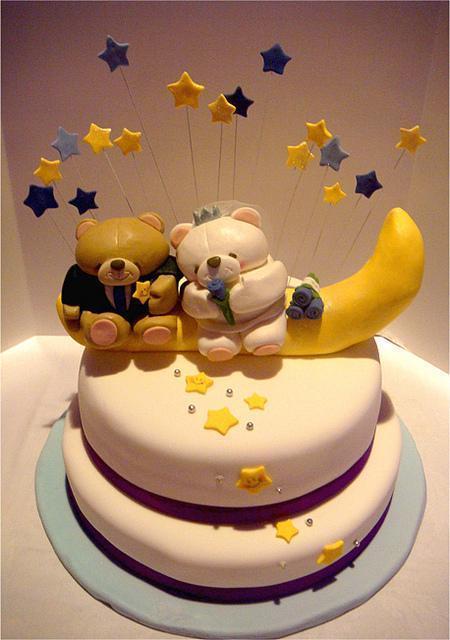How many teddy bears can be seen?
Give a very brief answer. 2. 